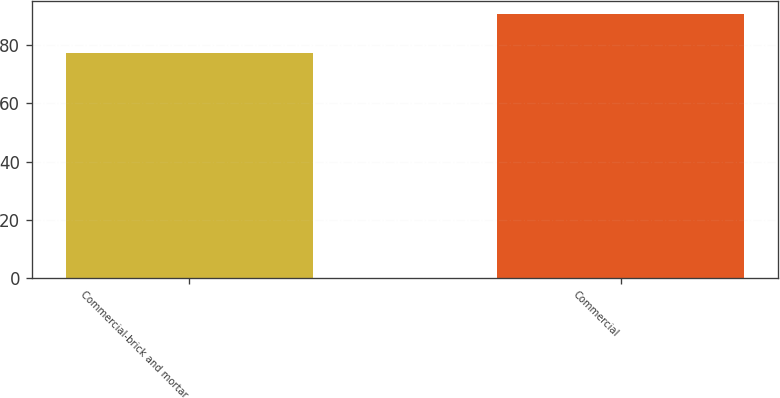Convert chart. <chart><loc_0><loc_0><loc_500><loc_500><bar_chart><fcel>Commercial-brick and mortar<fcel>Commercial<nl><fcel>77.2<fcel>90.6<nl></chart> 